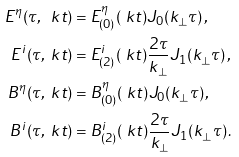<formula> <loc_0><loc_0><loc_500><loc_500>E ^ { \eta } ( \tau , \ k t ) & = E ^ { \eta } _ { ( 0 ) } ( \ k t ) J _ { 0 } ( k _ { \perp } \tau ) \, , \\ E ^ { i } ( \tau , \ k t ) & = E ^ { i } _ { ( 2 ) } ( \ k t ) \frac { 2 \tau } { k _ { \perp } } J _ { 1 } ( k _ { \perp } \tau ) \, , \\ B ^ { \eta } ( \tau , \ k t ) & = B ^ { \eta } _ { ( 0 ) } ( \ k t ) J _ { 0 } ( k _ { \perp } \tau ) \, , \\ B ^ { i } ( \tau , \ k t ) & = B ^ { i } _ { ( 2 ) } ( \ k t ) \frac { 2 \tau } { k _ { \perp } } J _ { 1 } ( k _ { \perp } \tau ) \, .</formula> 